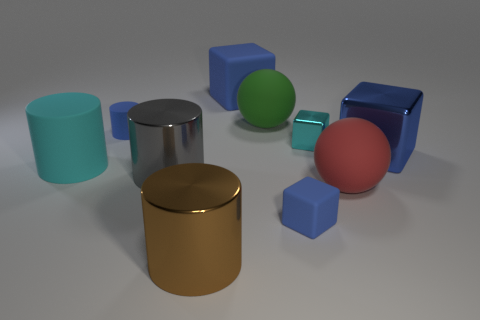Which object stands out the most in this setting, and why? The large gold cylinder stands out due to its shiny surface and unique color compared to the other objects. Gold is often associated with luxury and quality, making it naturally draw attention amidst the cooler tones present in the image.  Could this image represent any particular theme or concept? Indeed, this image might illustrate themes of variety and harmony among differences. Despite the disparity in shapes and colors, all objects share a level of uniformity in their gloss and texture. It emphasizes that diversity can coexist harmoniously while maintaining individual uniqueness. 